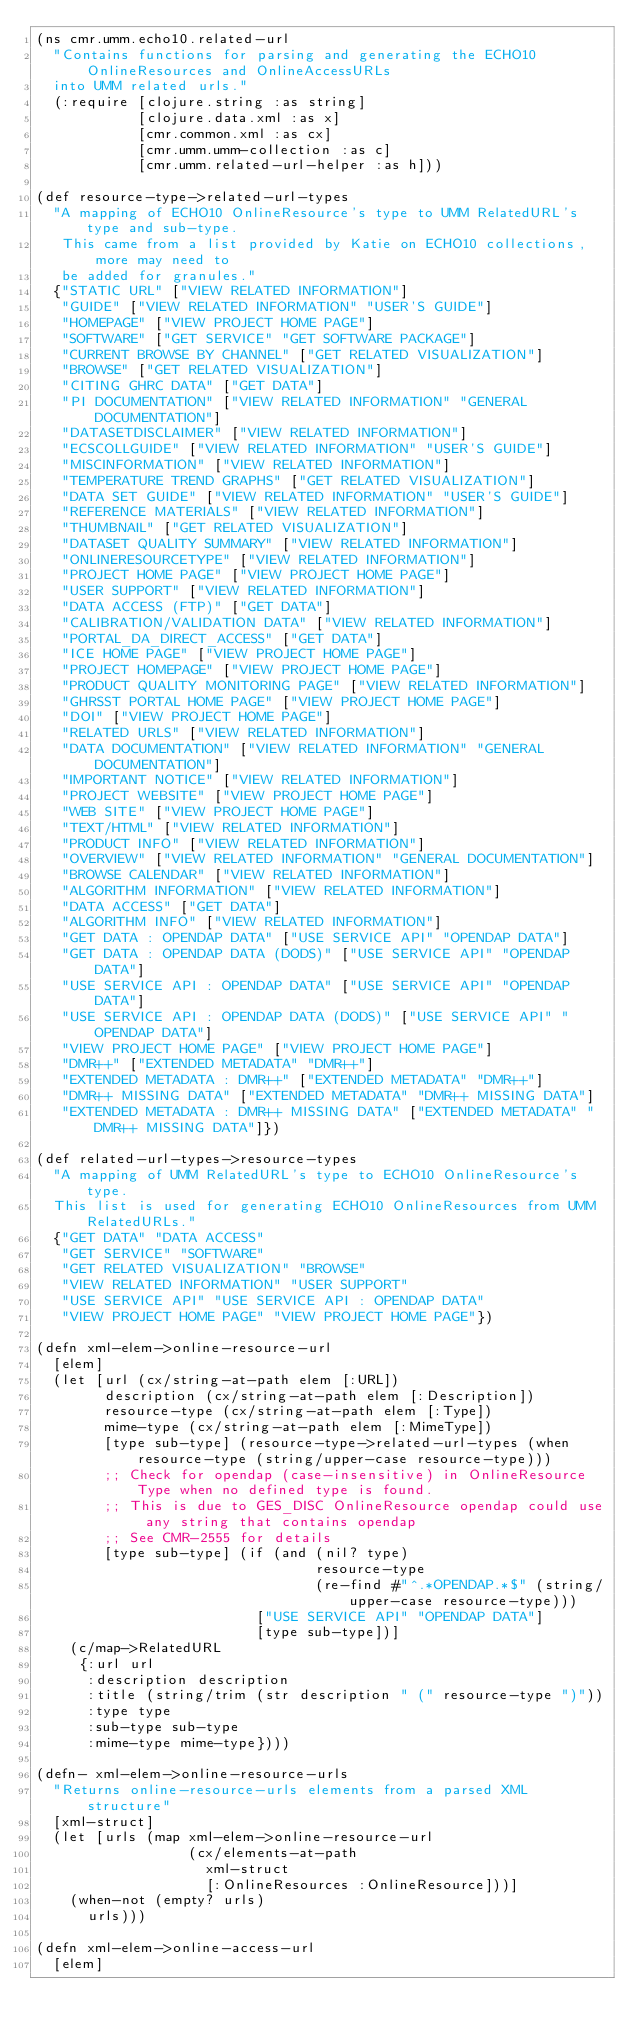Convert code to text. <code><loc_0><loc_0><loc_500><loc_500><_Clojure_>(ns cmr.umm.echo10.related-url
  "Contains functions for parsing and generating the ECHO10 OnlineResources and OnlineAccessURLs
  into UMM related urls."
  (:require [clojure.string :as string]
            [clojure.data.xml :as x]
            [cmr.common.xml :as cx]
            [cmr.umm.umm-collection :as c]
            [cmr.umm.related-url-helper :as h]))

(def resource-type->related-url-types
  "A mapping of ECHO10 OnlineResource's type to UMM RelatedURL's type and sub-type.
   This came from a list provided by Katie on ECHO10 collections, more may need to
   be added for granules."
  {"STATIC URL" ["VIEW RELATED INFORMATION"]
   "GUIDE" ["VIEW RELATED INFORMATION" "USER'S GUIDE"]
   "HOMEPAGE" ["VIEW PROJECT HOME PAGE"]
   "SOFTWARE" ["GET SERVICE" "GET SOFTWARE PACKAGE"]
   "CURRENT BROWSE BY CHANNEL" ["GET RELATED VISUALIZATION"]
   "BROWSE" ["GET RELATED VISUALIZATION"]
   "CITING GHRC DATA" ["GET DATA"]
   "PI DOCUMENTATION" ["VIEW RELATED INFORMATION" "GENERAL DOCUMENTATION"]
   "DATASETDISCLAIMER" ["VIEW RELATED INFORMATION"]
   "ECSCOLLGUIDE" ["VIEW RELATED INFORMATION" "USER'S GUIDE"]
   "MISCINFORMATION" ["VIEW RELATED INFORMATION"]
   "TEMPERATURE TREND GRAPHS" ["GET RELATED VISUALIZATION"]
   "DATA SET GUIDE" ["VIEW RELATED INFORMATION" "USER'S GUIDE"]
   "REFERENCE MATERIALS" ["VIEW RELATED INFORMATION"]
   "THUMBNAIL" ["GET RELATED VISUALIZATION"]
   "DATASET QUALITY SUMMARY" ["VIEW RELATED INFORMATION"]
   "ONLINERESOURCETYPE" ["VIEW RELATED INFORMATION"]
   "PROJECT HOME PAGE" ["VIEW PROJECT HOME PAGE"]
   "USER SUPPORT" ["VIEW RELATED INFORMATION"]
   "DATA ACCESS (FTP)" ["GET DATA"]
   "CALIBRATION/VALIDATION DATA" ["VIEW RELATED INFORMATION"]
   "PORTAL_DA_DIRECT_ACCESS" ["GET DATA"]
   "ICE HOME PAGE" ["VIEW PROJECT HOME PAGE"]
   "PROJECT HOMEPAGE" ["VIEW PROJECT HOME PAGE"]
   "PRODUCT QUALITY MONITORING PAGE" ["VIEW RELATED INFORMATION"]
   "GHRSST PORTAL HOME PAGE" ["VIEW PROJECT HOME PAGE"]
   "DOI" ["VIEW PROJECT HOME PAGE"]
   "RELATED URLS" ["VIEW RELATED INFORMATION"]
   "DATA DOCUMENTATION" ["VIEW RELATED INFORMATION" "GENERAL DOCUMENTATION"]
   "IMPORTANT NOTICE" ["VIEW RELATED INFORMATION"]
   "PROJECT WEBSITE" ["VIEW PROJECT HOME PAGE"]
   "WEB SITE" ["VIEW PROJECT HOME PAGE"]
   "TEXT/HTML" ["VIEW RELATED INFORMATION"]
   "PRODUCT INFO" ["VIEW RELATED INFORMATION"]
   "OVERVIEW" ["VIEW RELATED INFORMATION" "GENERAL DOCUMENTATION"]
   "BROWSE CALENDAR" ["VIEW RELATED INFORMATION"]
   "ALGORITHM INFORMATION" ["VIEW RELATED INFORMATION"]
   "DATA ACCESS" ["GET DATA"]
   "ALGORITHM INFO" ["VIEW RELATED INFORMATION"]
   "GET DATA : OPENDAP DATA" ["USE SERVICE API" "OPENDAP DATA"]
   "GET DATA : OPENDAP DATA (DODS)" ["USE SERVICE API" "OPENDAP DATA"]
   "USE SERVICE API : OPENDAP DATA" ["USE SERVICE API" "OPENDAP DATA"]
   "USE SERVICE API : OPENDAP DATA (DODS)" ["USE SERVICE API" "OPENDAP DATA"]
   "VIEW PROJECT HOME PAGE" ["VIEW PROJECT HOME PAGE"]
   "DMR++" ["EXTENDED METADATA" "DMR++"]
   "EXTENDED METADATA : DMR++" ["EXTENDED METADATA" "DMR++"]
   "DMR++ MISSING DATA" ["EXTENDED METADATA" "DMR++ MISSING DATA"]
   "EXTENDED METADATA : DMR++ MISSING DATA" ["EXTENDED METADATA" "DMR++ MISSING DATA"]})

(def related-url-types->resource-types
  "A mapping of UMM RelatedURL's type to ECHO10 OnlineResource's type.
  This list is used for generating ECHO10 OnlineResources from UMM RelatedURLs."
  {"GET DATA" "DATA ACCESS"
   "GET SERVICE" "SOFTWARE"
   "GET RELATED VISUALIZATION" "BROWSE"
   "VIEW RELATED INFORMATION" "USER SUPPORT"
   "USE SERVICE API" "USE SERVICE API : OPENDAP DATA"
   "VIEW PROJECT HOME PAGE" "VIEW PROJECT HOME PAGE"})

(defn xml-elem->online-resource-url
  [elem]
  (let [url (cx/string-at-path elem [:URL])
        description (cx/string-at-path elem [:Description])
        resource-type (cx/string-at-path elem [:Type])
        mime-type (cx/string-at-path elem [:MimeType])
        [type sub-type] (resource-type->related-url-types (when resource-type (string/upper-case resource-type)))
        ;; Check for opendap (case-insensitive) in OnlineResource Type when no defined type is found.
        ;; This is due to GES_DISC OnlineResource opendap could use any string that contains opendap
        ;; See CMR-2555 for details
        [type sub-type] (if (and (nil? type)
                                 resource-type
                                 (re-find #"^.*OPENDAP.*$" (string/upper-case resource-type)))
                          ["USE SERVICE API" "OPENDAP DATA"]
                          [type sub-type])]
    (c/map->RelatedURL
     {:url url
      :description description
      :title (string/trim (str description " (" resource-type ")"))
      :type type
      :sub-type sub-type
      :mime-type mime-type})))

(defn- xml-elem->online-resource-urls
  "Returns online-resource-urls elements from a parsed XML structure"
  [xml-struct]
  (let [urls (map xml-elem->online-resource-url
                  (cx/elements-at-path
                    xml-struct
                    [:OnlineResources :OnlineResource]))]
    (when-not (empty? urls)
      urls)))

(defn xml-elem->online-access-url
  [elem]</code> 